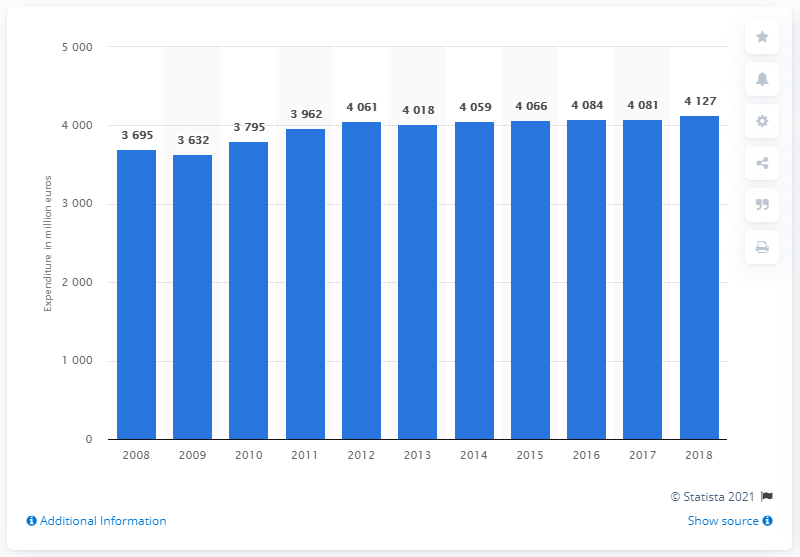Specify some key components in this picture. The final consumption of clothing in Finland in 2018 was 4,127 units. 